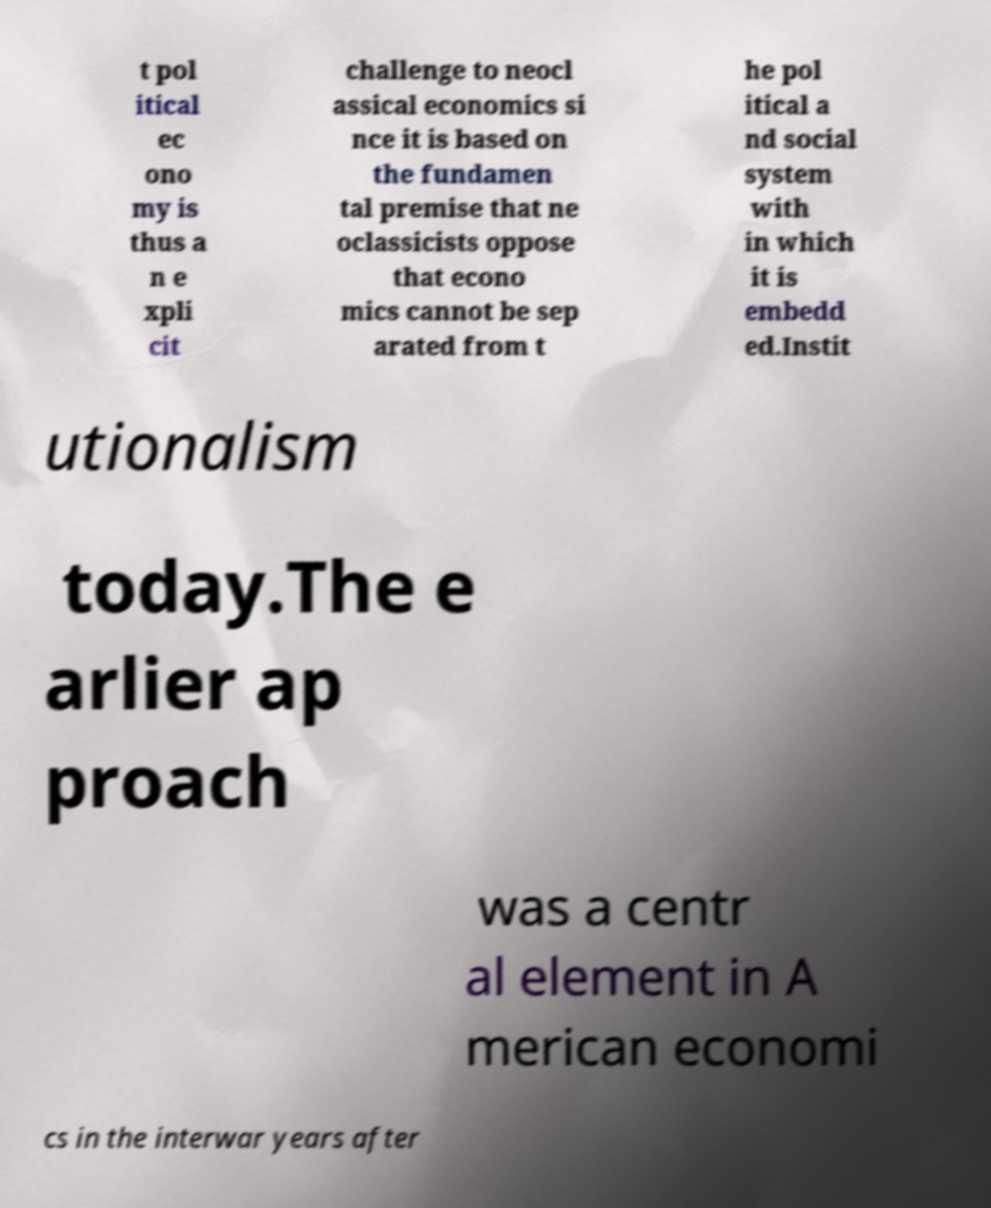There's text embedded in this image that I need extracted. Can you transcribe it verbatim? t pol itical ec ono my is thus a n e xpli cit challenge to neocl assical economics si nce it is based on the fundamen tal premise that ne oclassicists oppose that econo mics cannot be sep arated from t he pol itical a nd social system with in which it is embedd ed.Instit utionalism today.The e arlier ap proach was a centr al element in A merican economi cs in the interwar years after 